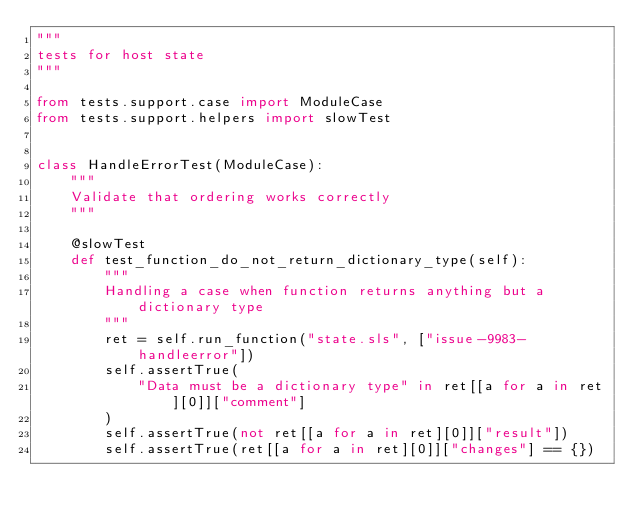<code> <loc_0><loc_0><loc_500><loc_500><_Python_>"""
tests for host state
"""

from tests.support.case import ModuleCase
from tests.support.helpers import slowTest


class HandleErrorTest(ModuleCase):
    """
    Validate that ordering works correctly
    """

    @slowTest
    def test_function_do_not_return_dictionary_type(self):
        """
        Handling a case when function returns anything but a dictionary type
        """
        ret = self.run_function("state.sls", ["issue-9983-handleerror"])
        self.assertTrue(
            "Data must be a dictionary type" in ret[[a for a in ret][0]]["comment"]
        )
        self.assertTrue(not ret[[a for a in ret][0]]["result"])
        self.assertTrue(ret[[a for a in ret][0]]["changes"] == {})
</code> 